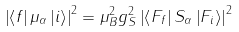Convert formula to latex. <formula><loc_0><loc_0><loc_500><loc_500>\left | \left \langle f \right | \mu _ { \alpha } \left | i \right \rangle \right | ^ { 2 } = \mu _ { B } ^ { 2 } g _ { S } ^ { 2 } \left | \left \langle F _ { f } \right | S _ { \alpha } \left | F _ { i } \right \rangle \right | ^ { 2 }</formula> 